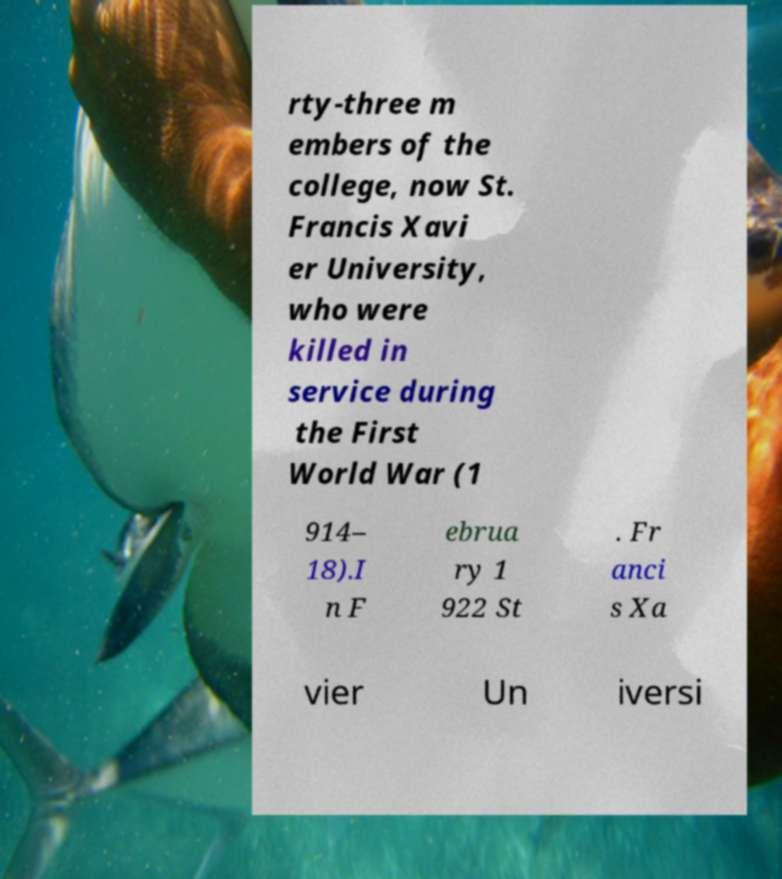Can you read and provide the text displayed in the image?This photo seems to have some interesting text. Can you extract and type it out for me? rty-three m embers of the college, now St. Francis Xavi er University, who were killed in service during the First World War (1 914– 18).I n F ebrua ry 1 922 St . Fr anci s Xa vier Un iversi 